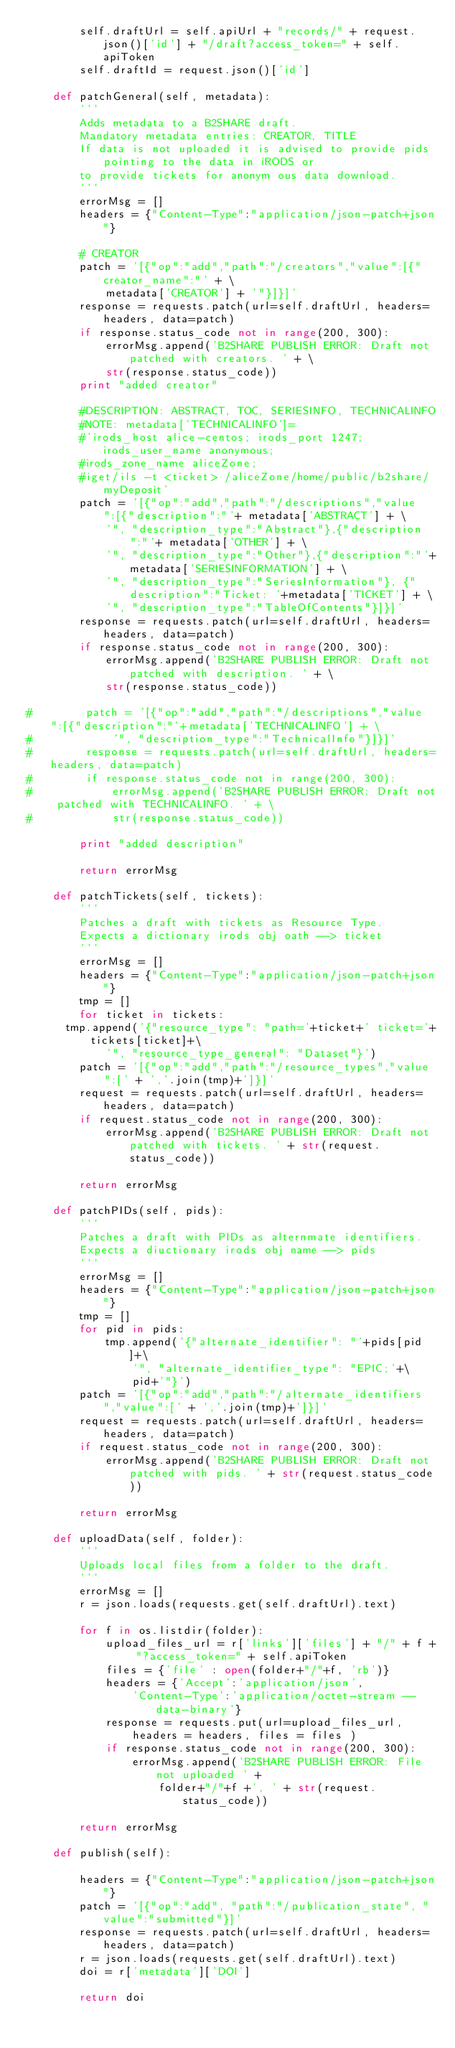<code> <loc_0><loc_0><loc_500><loc_500><_Python_>        self.draftUrl = self.apiUrl + "records/" + request.json()['id'] + "/draft?access_token=" + self.apiToken
        self.draftId = request.json()['id']

    def patchGeneral(self, metadata):
        '''
        Adds metadata to a B2SHARE draft.
        Mandatory metadata entries: CREATOR, TITLE
        If data is not uploaded it is advised to provide pids pointing to the data in iRODS or
        to provide tickets for anonym ous data download.
        '''
        errorMsg = []
        headers = {"Content-Type":"application/json-patch+json"}

        # CREATOR
        patch = '[{"op":"add","path":"/creators","value":[{"creator_name":"' + \
            metadata['CREATOR'] + '"}]}]'
        response = requests.patch(url=self.draftUrl, headers=headers, data=patch)
        if response.status_code not in range(200, 300):
            errorMsg.append('B2SHARE PUBLISH ERROR: Draft not patched with creators. ' + \
            str(response.status_code))
        print "added creator"

        #DESCRIPTION: ABSTRACT, TOC, SERIESINFO, TECHNICALINFO
        #NOTE: metadata['TECHNICALINFO']=
        #'irods_host alice-centos; irods_port 1247; irods_user_name anonymous;
        #irods_zone_name aliceZone;
        #iget/ils -t <ticket> /aliceZone/home/public/b2share/myDeposit'
        patch = '[{"op":"add","path":"/descriptions","value":[{"description":"'+ metadata['ABSTRACT'] + \
            '", "description_type":"Abstract"},{"description":"'+ metadata['OTHER'] + \
            '", "description_type":"Other"},{"description":"'+metadata['SERIESINFORMATION'] + \
            '", "description_type":"SeriesInformation"}, {"description":"Ticket: '+metadata['TICKET'] + \
            '", "description_type":"TableOfContents"}]}]'
        response = requests.patch(url=self.draftUrl, headers=headers, data=patch)
        if response.status_code not in range(200, 300):
            errorMsg.append('B2SHARE PUBLISH ERROR: Draft not patched with description. ' + \
            str(response.status_code))

#        patch = '[{"op":"add","path":"/descriptions","value":[{"description":"'+metadata['TECHNICALINFO'] + \
#            '", "description_type":"TechnicalInfo"}]}]'
#        response = requests.patch(url=self.draftUrl, headers=headers, data=patch)
#        if response.status_code not in range(200, 300):
#            errorMsg.append('B2SHARE PUBLISH ERROR: Draft not patched with TECHNICALINFO. ' + \
#            str(response.status_code))

        print "added description"

        return errorMsg

    def patchTickets(self, tickets):
        '''
        Patches a draft with tickets as Resource Type.
        Expects a dictionary irods obj oath --> ticket
        '''
        errorMsg = []
        headers = {"Content-Type":"application/json-patch+json"}
        tmp = []
        for ticket in tickets:
	    tmp.append('{"resource_type": "path='+ticket+' ticket='+tickets[ticket]+\
            '", "resource_type_general": "Dataset"}')
        patch = '[{"op":"add","path":"/resource_types","value":[' + ','.join(tmp)+']}]'
        request = requests.patch(url=self.draftUrl, headers=headers, data=patch)
        if request.status_code not in range(200, 300):
            errorMsg.append('B2SHARE PUBLISH ERROR: Draft not patched with tickets. ' + str(request.status_code))

        return errorMsg

    def patchPIDs(self, pids):
        '''
        Patches a draft with PIDs as alternmate identifiers.
        Expects a diuctionary irods obj name --> pids
        '''
        errorMsg = []
        headers = {"Content-Type":"application/json-patch+json"}
        tmp = []
        for pid in pids:
            tmp.append('{"alternate_identifier": "'+pids[pid]+\
                '", "alternate_identifier_type": "EPIC;'+\
                pid+'"}')
        patch = '[{"op":"add","path":"/alternate_identifiers","value":[' + ','.join(tmp)+']}]'
        request = requests.patch(url=self.draftUrl, headers=headers, data=patch)
        if request.status_code not in range(200, 300):
            errorMsg.append('B2SHARE PUBLISH ERROR: Draft not patched with pids. ' + str(request.status_code))

        return errorMsg

    def uploadData(self, folder):
        '''
        Uploads local files from a folder to the draft.
        '''
        errorMsg = []
        r = json.loads(requests.get(self.draftUrl).text)

        for f in os.listdir(folder):
            upload_files_url = r['links']['files'] + "/" + f + "?access_token=" + self.apiToken
            files = {'file' : open(folder+"/"+f, 'rb')}
            headers = {'Accept':'application/json',
                'Content-Type':'application/octet-stream --data-binary'}
            response = requests.put(url=upload_files_url,
                headers = headers, files = files )
            if response.status_code not in range(200, 300):
                errorMsg.append('B2SHARE PUBLISH ERROR: File not uploaded ' +
                    folder+"/"+f +', ' + str(request.status_code))

        return errorMsg

    def publish(self):

        headers = {"Content-Type":"application/json-patch+json"}
        patch = '[{"op":"add", "path":"/publication_state", "value":"submitted"}]'
        response = requests.patch(url=self.draftUrl, headers=headers, data=patch)
        r = json.loads(requests.get(self.draftUrl).text)    
        doi = r['metadata']['DOI']        

        return doi
</code> 